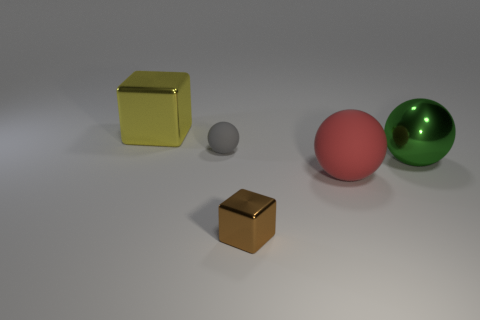Add 2 big yellow cylinders. How many objects exist? 7 Subtract all big metal spheres. How many spheres are left? 2 Subtract all cubes. How many objects are left? 3 Subtract 1 spheres. How many spheres are left? 2 Subtract all green balls. How many balls are left? 2 Subtract all cyan cubes. How many gray balls are left? 1 Subtract all tiny gray rubber balls. Subtract all small gray matte objects. How many objects are left? 3 Add 4 large green shiny spheres. How many large green shiny spheres are left? 5 Add 4 tiny yellow shiny cylinders. How many tiny yellow shiny cylinders exist? 4 Subtract 0 blue blocks. How many objects are left? 5 